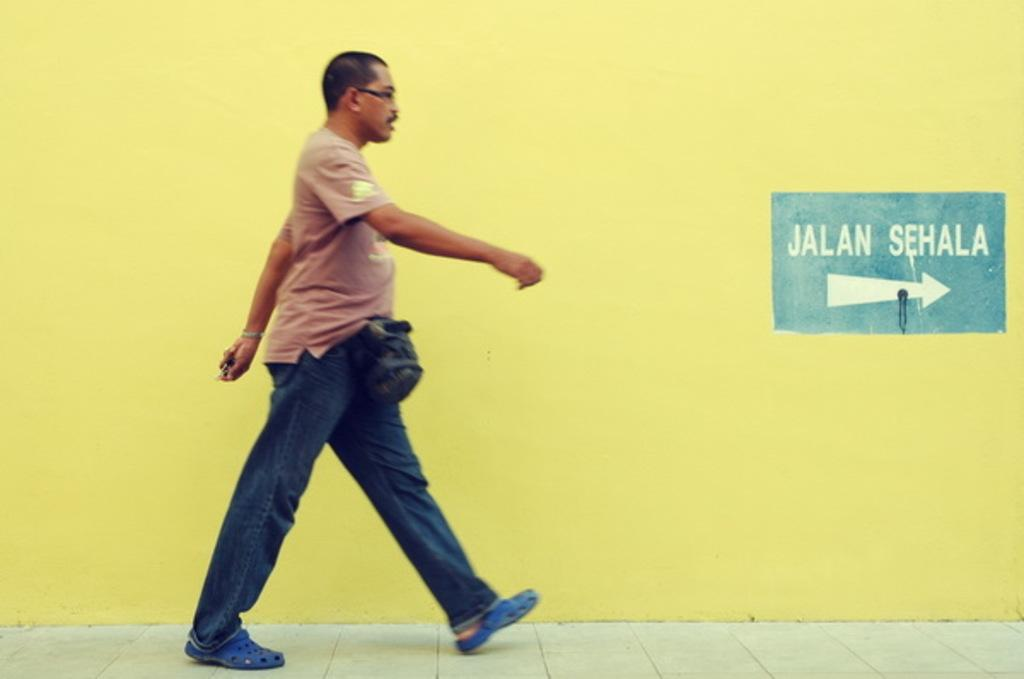What is the main subject of the image? There is a man in the image. What is the man doing in the image? The man is walking on the ground. Can you describe the man's appearance? The man is wearing spectacles, a t-shirt, pants, and shoes. What can be seen in the background of the image? There is a yellow color wall in the background of the image. What type of mint is growing on the man's head in the image? There is no mint growing on the man's head in the image. Can you see any wounds on the man in the image? There is no indication of any wounds on the man in the image. Is there a kettle visible in the image? There is no kettle present in the image. 